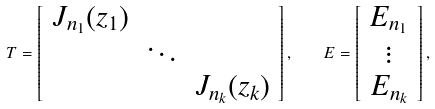Convert formula to latex. <formula><loc_0><loc_0><loc_500><loc_500>T = \left [ \begin{array} { c c c } J _ { n _ { 1 } } ( z _ { 1 } ) & & \\ & \ddots & \\ & & J _ { n _ { k } } ( z _ { k } ) \end{array} \right ] , \quad E = \left [ \begin{array} { c } E _ { n _ { 1 } } \\ \vdots \\ E _ { n _ { k } } \end{array} \right ] ,</formula> 